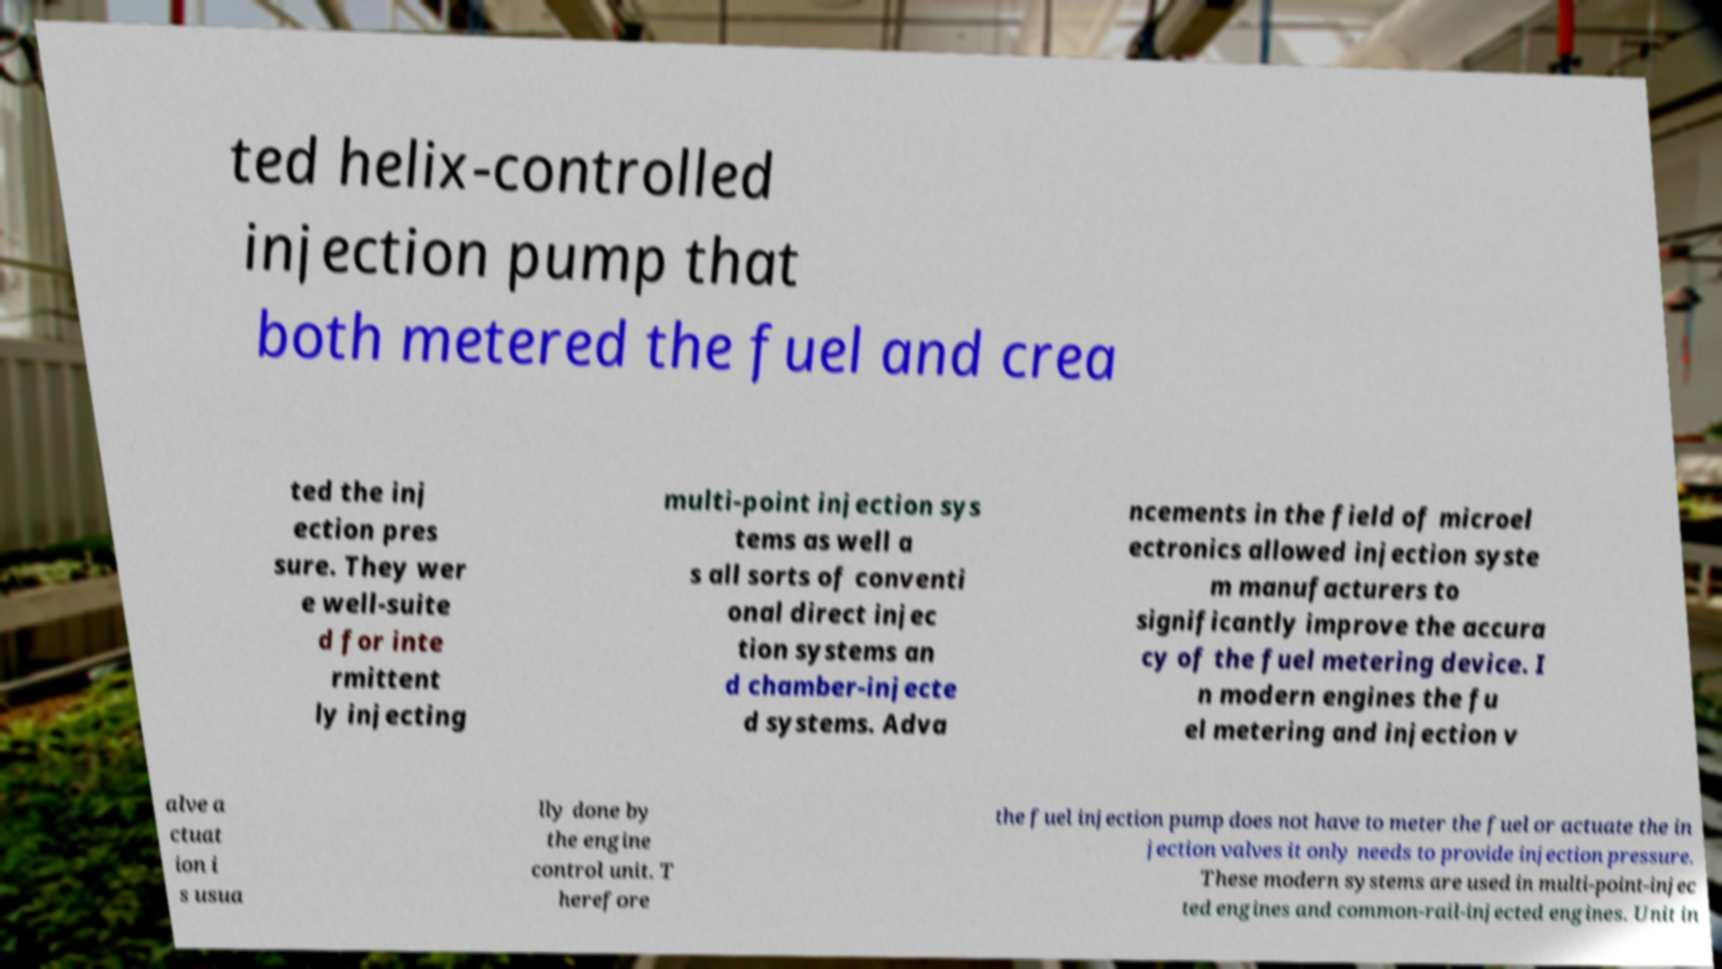Please read and relay the text visible in this image. What does it say? ted helix-controlled injection pump that both metered the fuel and crea ted the inj ection pres sure. They wer e well-suite d for inte rmittent ly injecting multi-point injection sys tems as well a s all sorts of conventi onal direct injec tion systems an d chamber-injecte d systems. Adva ncements in the field of microel ectronics allowed injection syste m manufacturers to significantly improve the accura cy of the fuel metering device. I n modern engines the fu el metering and injection v alve a ctuat ion i s usua lly done by the engine control unit. T herefore the fuel injection pump does not have to meter the fuel or actuate the in jection valves it only needs to provide injection pressure. These modern systems are used in multi-point-injec ted engines and common-rail-injected engines. Unit in 